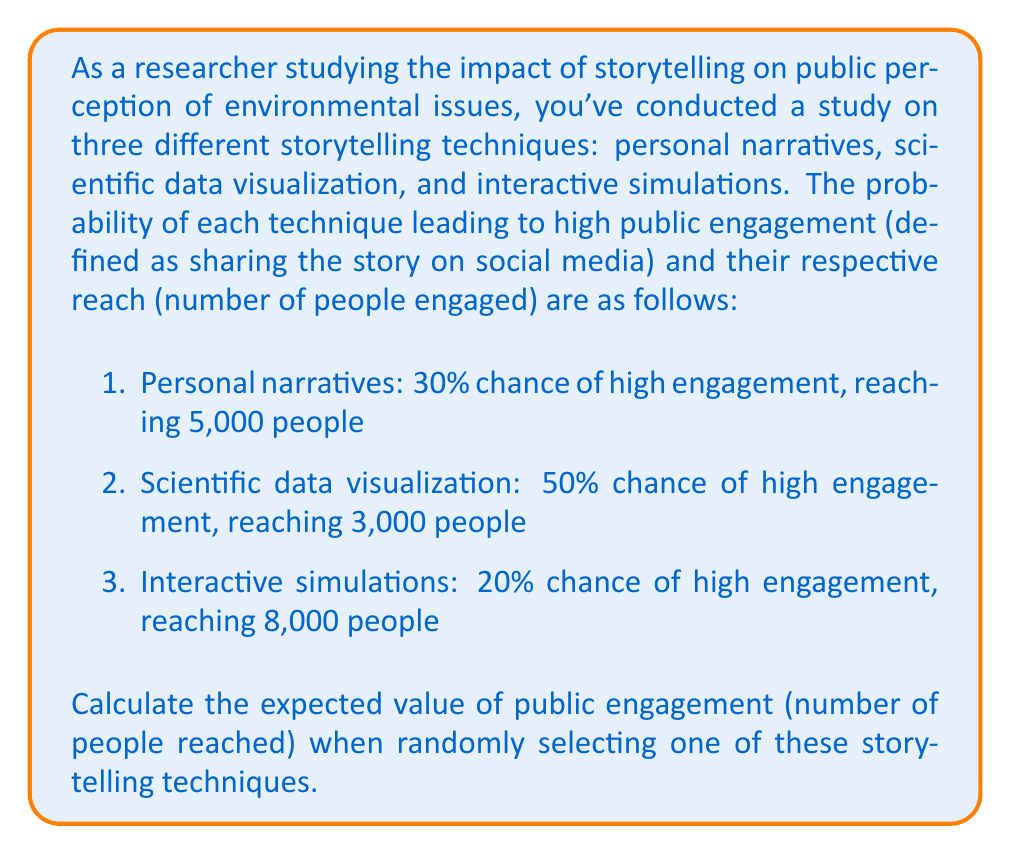Solve this math problem. To solve this problem, we need to calculate the expected value of the random variable representing public engagement. Let's approach this step-by-step:

1. Define the random variable:
   Let $X$ be the number of people reached through high engagement.

2. Identify the possible outcomes and their probabilities:
   - $P(X = 5000) = 0.30$ (personal narratives)
   - $P(X = 3000) = 0.50$ (scientific data visualization)
   - $P(X = 8000) = 0.20$ (interactive simulations)

3. Recall the formula for expected value:
   $$E(X) = \sum_{i=1}^{n} x_i \cdot P(X = x_i)$$

4. Calculate the expected value:
   $$\begin{align*}
   E(X) &= 5000 \cdot 0.30 + 3000 \cdot 0.50 + 8000 \cdot 0.20 \\
   &= 1500 + 1500 + 1600 \\
   &= 4600
   \end{align*}$$

Therefore, the expected value of public engagement when randomly selecting one of these storytelling techniques is 4,600 people.
Answer: 4,600 people 